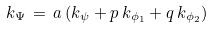<formula> <loc_0><loc_0><loc_500><loc_500>k _ { \Psi } \, = \, a \, ( k _ { \psi } + p \, k _ { \phi _ { 1 } } + q \, k _ { \phi _ { 2 } } )</formula> 